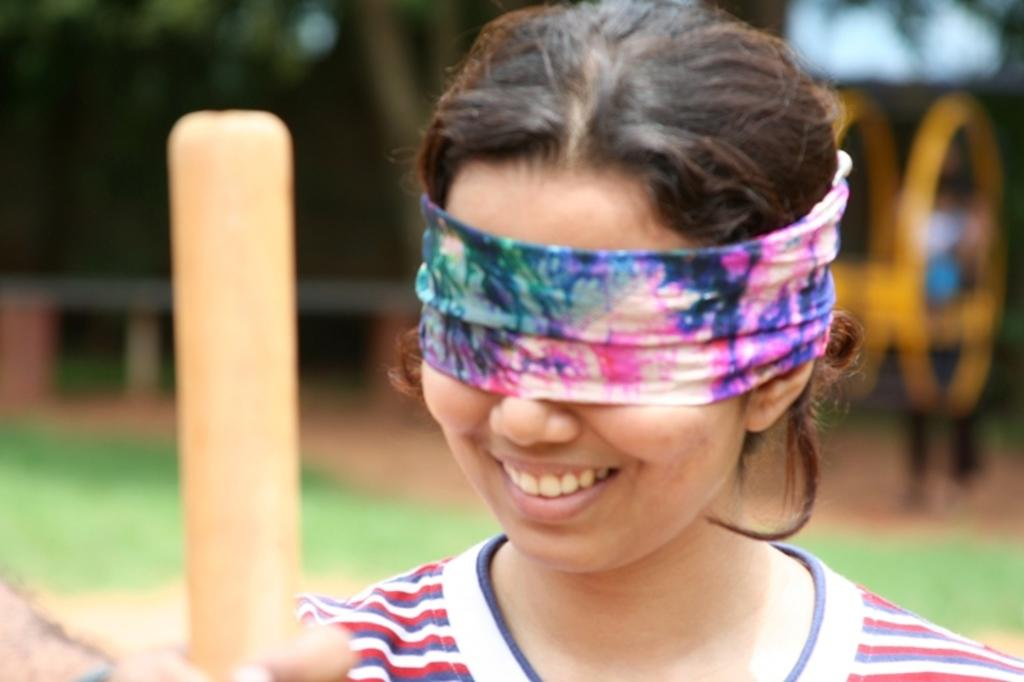Who is the main subject in the image? There is a woman in the image. What is the woman doing in the image? The woman has a cloth tied around her eyes and is holding a bat. What type of brass instrument is the woman playing in the image? There is no brass instrument present in the image; the woman is holding a bat. Can you see a yak in the image? There is no yak present in the image. 